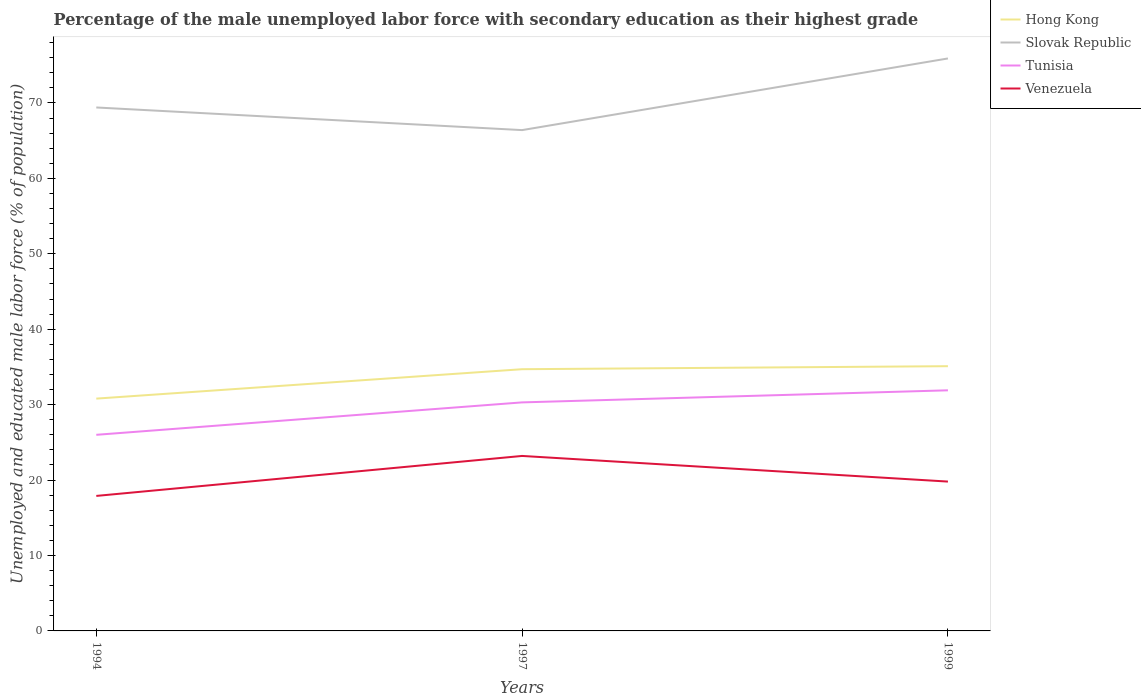How many different coloured lines are there?
Offer a very short reply. 4. Does the line corresponding to Hong Kong intersect with the line corresponding to Tunisia?
Provide a short and direct response. No. Is the number of lines equal to the number of legend labels?
Make the answer very short. Yes. Across all years, what is the maximum percentage of the unemployed male labor force with secondary education in Hong Kong?
Provide a short and direct response. 30.8. In which year was the percentage of the unemployed male labor force with secondary education in Hong Kong maximum?
Ensure brevity in your answer.  1994. What is the total percentage of the unemployed male labor force with secondary education in Hong Kong in the graph?
Your response must be concise. -0.4. What is the difference between the highest and the second highest percentage of the unemployed male labor force with secondary education in Venezuela?
Provide a short and direct response. 5.3. What is the difference between the highest and the lowest percentage of the unemployed male labor force with secondary education in Slovak Republic?
Give a very brief answer. 1. What is the difference between two consecutive major ticks on the Y-axis?
Give a very brief answer. 10. Are the values on the major ticks of Y-axis written in scientific E-notation?
Give a very brief answer. No. Does the graph contain any zero values?
Offer a terse response. No. Where does the legend appear in the graph?
Make the answer very short. Top right. What is the title of the graph?
Give a very brief answer. Percentage of the male unemployed labor force with secondary education as their highest grade. What is the label or title of the X-axis?
Your answer should be compact. Years. What is the label or title of the Y-axis?
Keep it short and to the point. Unemployed and educated male labor force (% of population). What is the Unemployed and educated male labor force (% of population) of Hong Kong in 1994?
Offer a very short reply. 30.8. What is the Unemployed and educated male labor force (% of population) in Slovak Republic in 1994?
Offer a very short reply. 69.4. What is the Unemployed and educated male labor force (% of population) of Venezuela in 1994?
Ensure brevity in your answer.  17.9. What is the Unemployed and educated male labor force (% of population) in Hong Kong in 1997?
Your response must be concise. 34.7. What is the Unemployed and educated male labor force (% of population) of Slovak Republic in 1997?
Provide a short and direct response. 66.4. What is the Unemployed and educated male labor force (% of population) of Tunisia in 1997?
Give a very brief answer. 30.3. What is the Unemployed and educated male labor force (% of population) in Venezuela in 1997?
Keep it short and to the point. 23.2. What is the Unemployed and educated male labor force (% of population) of Hong Kong in 1999?
Your response must be concise. 35.1. What is the Unemployed and educated male labor force (% of population) of Slovak Republic in 1999?
Your answer should be compact. 75.9. What is the Unemployed and educated male labor force (% of population) in Tunisia in 1999?
Provide a short and direct response. 31.9. What is the Unemployed and educated male labor force (% of population) of Venezuela in 1999?
Keep it short and to the point. 19.8. Across all years, what is the maximum Unemployed and educated male labor force (% of population) in Hong Kong?
Offer a terse response. 35.1. Across all years, what is the maximum Unemployed and educated male labor force (% of population) in Slovak Republic?
Your response must be concise. 75.9. Across all years, what is the maximum Unemployed and educated male labor force (% of population) of Tunisia?
Ensure brevity in your answer.  31.9. Across all years, what is the maximum Unemployed and educated male labor force (% of population) of Venezuela?
Provide a short and direct response. 23.2. Across all years, what is the minimum Unemployed and educated male labor force (% of population) of Hong Kong?
Your answer should be compact. 30.8. Across all years, what is the minimum Unemployed and educated male labor force (% of population) in Slovak Republic?
Keep it short and to the point. 66.4. Across all years, what is the minimum Unemployed and educated male labor force (% of population) in Tunisia?
Your response must be concise. 26. Across all years, what is the minimum Unemployed and educated male labor force (% of population) in Venezuela?
Make the answer very short. 17.9. What is the total Unemployed and educated male labor force (% of population) of Hong Kong in the graph?
Your answer should be very brief. 100.6. What is the total Unemployed and educated male labor force (% of population) of Slovak Republic in the graph?
Make the answer very short. 211.7. What is the total Unemployed and educated male labor force (% of population) in Tunisia in the graph?
Your answer should be compact. 88.2. What is the total Unemployed and educated male labor force (% of population) in Venezuela in the graph?
Make the answer very short. 60.9. What is the difference between the Unemployed and educated male labor force (% of population) of Hong Kong in 1994 and that in 1997?
Provide a succinct answer. -3.9. What is the difference between the Unemployed and educated male labor force (% of population) of Slovak Republic in 1994 and that in 1997?
Provide a succinct answer. 3. What is the difference between the Unemployed and educated male labor force (% of population) of Tunisia in 1994 and that in 1997?
Your answer should be very brief. -4.3. What is the difference between the Unemployed and educated male labor force (% of population) in Hong Kong in 1994 and that in 1999?
Your answer should be very brief. -4.3. What is the difference between the Unemployed and educated male labor force (% of population) in Hong Kong in 1997 and that in 1999?
Your response must be concise. -0.4. What is the difference between the Unemployed and educated male labor force (% of population) in Tunisia in 1997 and that in 1999?
Provide a short and direct response. -1.6. What is the difference between the Unemployed and educated male labor force (% of population) in Hong Kong in 1994 and the Unemployed and educated male labor force (% of population) in Slovak Republic in 1997?
Your answer should be compact. -35.6. What is the difference between the Unemployed and educated male labor force (% of population) in Hong Kong in 1994 and the Unemployed and educated male labor force (% of population) in Tunisia in 1997?
Offer a very short reply. 0.5. What is the difference between the Unemployed and educated male labor force (% of population) in Slovak Republic in 1994 and the Unemployed and educated male labor force (% of population) in Tunisia in 1997?
Your response must be concise. 39.1. What is the difference between the Unemployed and educated male labor force (% of population) of Slovak Republic in 1994 and the Unemployed and educated male labor force (% of population) of Venezuela in 1997?
Your response must be concise. 46.2. What is the difference between the Unemployed and educated male labor force (% of population) of Tunisia in 1994 and the Unemployed and educated male labor force (% of population) of Venezuela in 1997?
Provide a short and direct response. 2.8. What is the difference between the Unemployed and educated male labor force (% of population) of Hong Kong in 1994 and the Unemployed and educated male labor force (% of population) of Slovak Republic in 1999?
Your answer should be very brief. -45.1. What is the difference between the Unemployed and educated male labor force (% of population) in Hong Kong in 1994 and the Unemployed and educated male labor force (% of population) in Venezuela in 1999?
Provide a short and direct response. 11. What is the difference between the Unemployed and educated male labor force (% of population) in Slovak Republic in 1994 and the Unemployed and educated male labor force (% of population) in Tunisia in 1999?
Provide a short and direct response. 37.5. What is the difference between the Unemployed and educated male labor force (% of population) in Slovak Republic in 1994 and the Unemployed and educated male labor force (% of population) in Venezuela in 1999?
Keep it short and to the point. 49.6. What is the difference between the Unemployed and educated male labor force (% of population) of Hong Kong in 1997 and the Unemployed and educated male labor force (% of population) of Slovak Republic in 1999?
Provide a succinct answer. -41.2. What is the difference between the Unemployed and educated male labor force (% of population) of Hong Kong in 1997 and the Unemployed and educated male labor force (% of population) of Tunisia in 1999?
Ensure brevity in your answer.  2.8. What is the difference between the Unemployed and educated male labor force (% of population) of Hong Kong in 1997 and the Unemployed and educated male labor force (% of population) of Venezuela in 1999?
Provide a succinct answer. 14.9. What is the difference between the Unemployed and educated male labor force (% of population) of Slovak Republic in 1997 and the Unemployed and educated male labor force (% of population) of Tunisia in 1999?
Provide a succinct answer. 34.5. What is the difference between the Unemployed and educated male labor force (% of population) of Slovak Republic in 1997 and the Unemployed and educated male labor force (% of population) of Venezuela in 1999?
Provide a succinct answer. 46.6. What is the average Unemployed and educated male labor force (% of population) in Hong Kong per year?
Ensure brevity in your answer.  33.53. What is the average Unemployed and educated male labor force (% of population) in Slovak Republic per year?
Your answer should be very brief. 70.57. What is the average Unemployed and educated male labor force (% of population) of Tunisia per year?
Your answer should be compact. 29.4. What is the average Unemployed and educated male labor force (% of population) in Venezuela per year?
Ensure brevity in your answer.  20.3. In the year 1994, what is the difference between the Unemployed and educated male labor force (% of population) in Hong Kong and Unemployed and educated male labor force (% of population) in Slovak Republic?
Provide a succinct answer. -38.6. In the year 1994, what is the difference between the Unemployed and educated male labor force (% of population) of Hong Kong and Unemployed and educated male labor force (% of population) of Venezuela?
Offer a terse response. 12.9. In the year 1994, what is the difference between the Unemployed and educated male labor force (% of population) of Slovak Republic and Unemployed and educated male labor force (% of population) of Tunisia?
Your answer should be very brief. 43.4. In the year 1994, what is the difference between the Unemployed and educated male labor force (% of population) of Slovak Republic and Unemployed and educated male labor force (% of population) of Venezuela?
Provide a succinct answer. 51.5. In the year 1994, what is the difference between the Unemployed and educated male labor force (% of population) of Tunisia and Unemployed and educated male labor force (% of population) of Venezuela?
Offer a very short reply. 8.1. In the year 1997, what is the difference between the Unemployed and educated male labor force (% of population) in Hong Kong and Unemployed and educated male labor force (% of population) in Slovak Republic?
Your answer should be very brief. -31.7. In the year 1997, what is the difference between the Unemployed and educated male labor force (% of population) in Hong Kong and Unemployed and educated male labor force (% of population) in Tunisia?
Your response must be concise. 4.4. In the year 1997, what is the difference between the Unemployed and educated male labor force (% of population) in Slovak Republic and Unemployed and educated male labor force (% of population) in Tunisia?
Offer a terse response. 36.1. In the year 1997, what is the difference between the Unemployed and educated male labor force (% of population) in Slovak Republic and Unemployed and educated male labor force (% of population) in Venezuela?
Ensure brevity in your answer.  43.2. In the year 1999, what is the difference between the Unemployed and educated male labor force (% of population) in Hong Kong and Unemployed and educated male labor force (% of population) in Slovak Republic?
Make the answer very short. -40.8. In the year 1999, what is the difference between the Unemployed and educated male labor force (% of population) of Hong Kong and Unemployed and educated male labor force (% of population) of Venezuela?
Provide a succinct answer. 15.3. In the year 1999, what is the difference between the Unemployed and educated male labor force (% of population) of Slovak Republic and Unemployed and educated male labor force (% of population) of Venezuela?
Offer a terse response. 56.1. In the year 1999, what is the difference between the Unemployed and educated male labor force (% of population) in Tunisia and Unemployed and educated male labor force (% of population) in Venezuela?
Offer a terse response. 12.1. What is the ratio of the Unemployed and educated male labor force (% of population) in Hong Kong in 1994 to that in 1997?
Offer a terse response. 0.89. What is the ratio of the Unemployed and educated male labor force (% of population) of Slovak Republic in 1994 to that in 1997?
Your answer should be compact. 1.05. What is the ratio of the Unemployed and educated male labor force (% of population) in Tunisia in 1994 to that in 1997?
Your response must be concise. 0.86. What is the ratio of the Unemployed and educated male labor force (% of population) of Venezuela in 1994 to that in 1997?
Offer a terse response. 0.77. What is the ratio of the Unemployed and educated male labor force (% of population) in Hong Kong in 1994 to that in 1999?
Your answer should be compact. 0.88. What is the ratio of the Unemployed and educated male labor force (% of population) in Slovak Republic in 1994 to that in 1999?
Offer a very short reply. 0.91. What is the ratio of the Unemployed and educated male labor force (% of population) in Tunisia in 1994 to that in 1999?
Offer a terse response. 0.81. What is the ratio of the Unemployed and educated male labor force (% of population) in Venezuela in 1994 to that in 1999?
Your answer should be compact. 0.9. What is the ratio of the Unemployed and educated male labor force (% of population) of Hong Kong in 1997 to that in 1999?
Keep it short and to the point. 0.99. What is the ratio of the Unemployed and educated male labor force (% of population) in Slovak Republic in 1997 to that in 1999?
Your answer should be compact. 0.87. What is the ratio of the Unemployed and educated male labor force (% of population) in Tunisia in 1997 to that in 1999?
Give a very brief answer. 0.95. What is the ratio of the Unemployed and educated male labor force (% of population) in Venezuela in 1997 to that in 1999?
Provide a short and direct response. 1.17. What is the difference between the highest and the second highest Unemployed and educated male labor force (% of population) in Tunisia?
Your answer should be very brief. 1.6. What is the difference between the highest and the second highest Unemployed and educated male labor force (% of population) in Venezuela?
Make the answer very short. 3.4. What is the difference between the highest and the lowest Unemployed and educated male labor force (% of population) in Hong Kong?
Provide a succinct answer. 4.3. What is the difference between the highest and the lowest Unemployed and educated male labor force (% of population) of Slovak Republic?
Give a very brief answer. 9.5. 